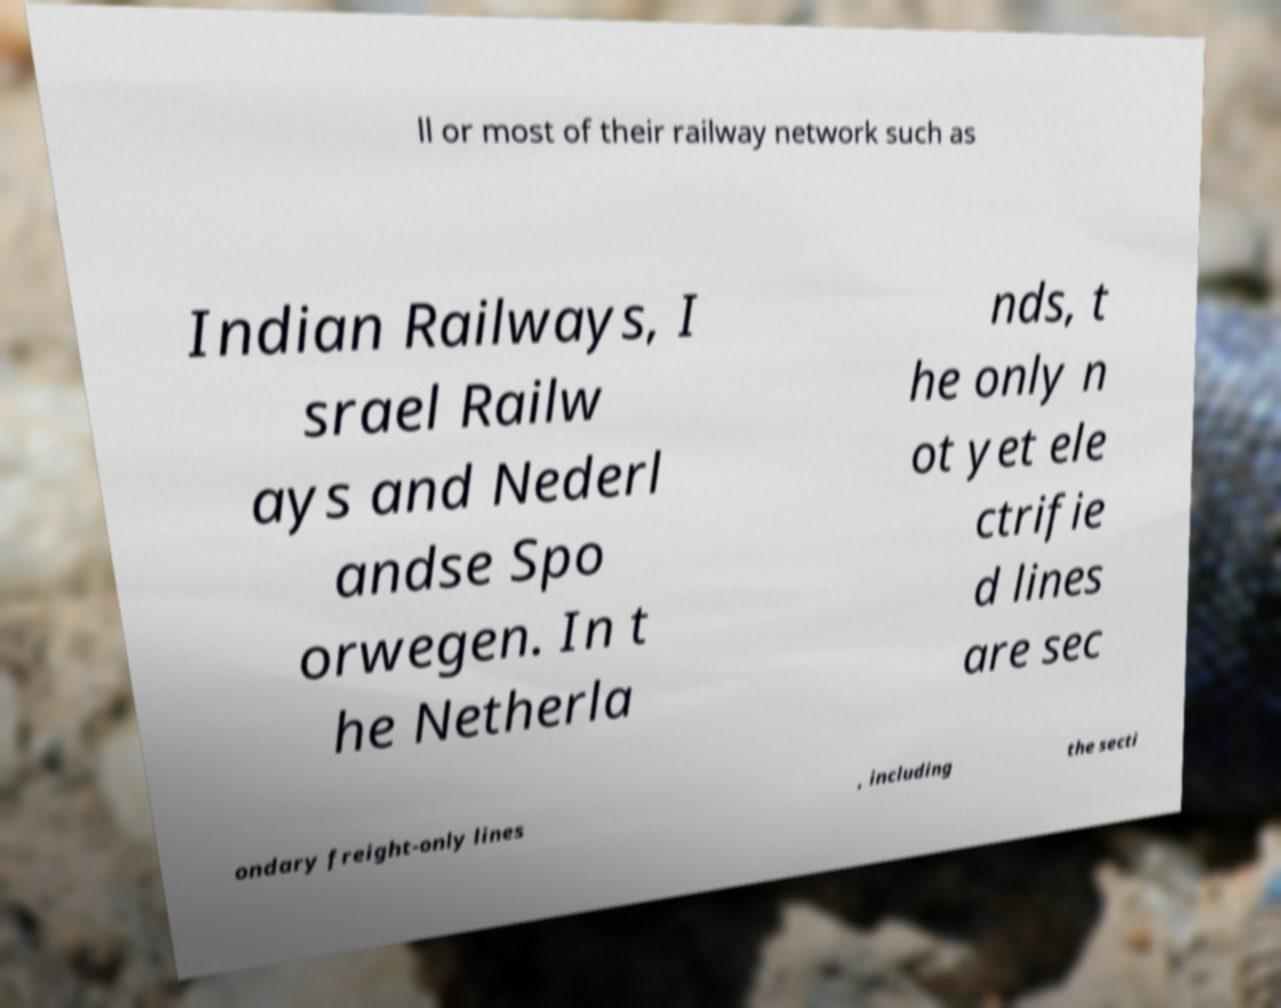Could you extract and type out the text from this image? ll or most of their railway network such as Indian Railways, I srael Railw ays and Nederl andse Spo orwegen. In t he Netherla nds, t he only n ot yet ele ctrifie d lines are sec ondary freight-only lines , including the secti 